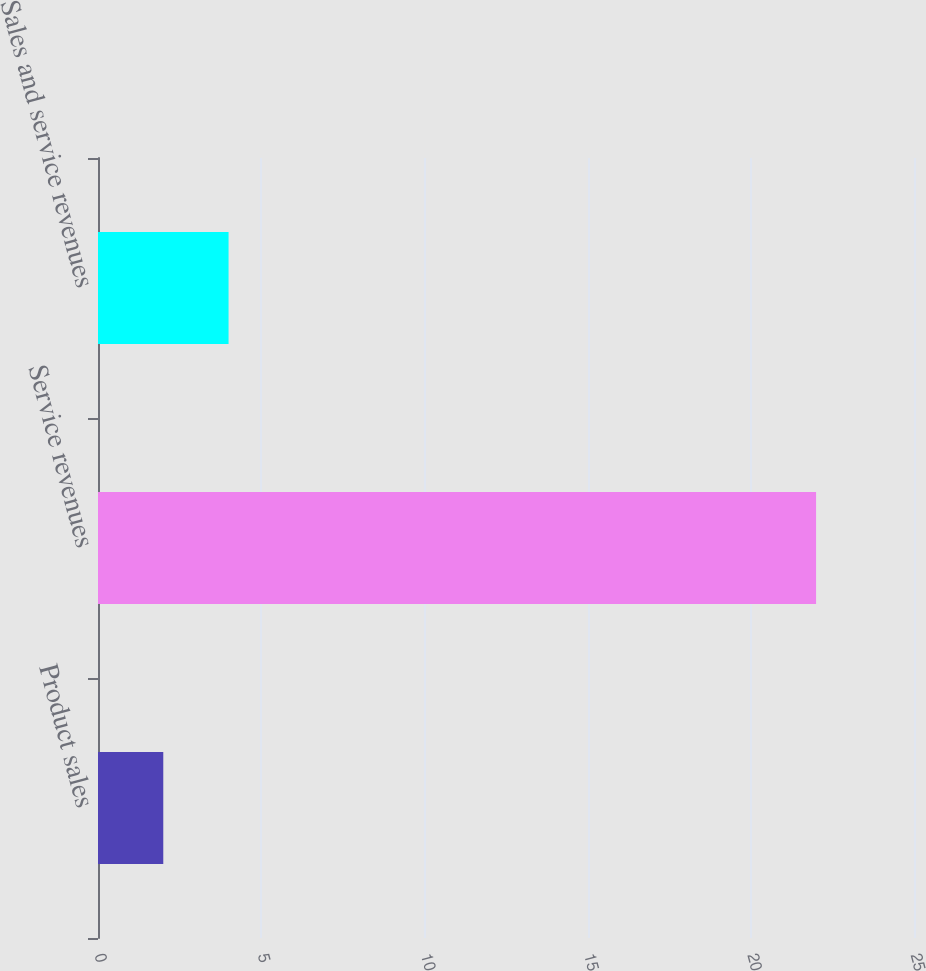Convert chart to OTSL. <chart><loc_0><loc_0><loc_500><loc_500><bar_chart><fcel>Product sales<fcel>Service revenues<fcel>Sales and service revenues<nl><fcel>2<fcel>22<fcel>4<nl></chart> 